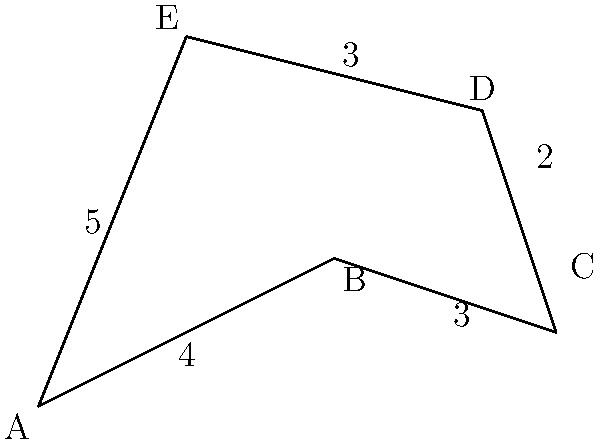As a political advisor aiming to become the youngest UN Secretary-General, you're analyzing a map of a disputed territory. The irregular polygon ABCDE represents the contested borders. Given that the lengths of the sides are AB = 4 units, BC = 3 units, CD = 2 units, DE = 3 units, and EA = 5 units, what is the perimeter of this territory in units? To find the perimeter of the irregular polygon ABCDE, we need to sum up the lengths of all its sides. Let's break it down step by step:

1. Side AB = 4 units
2. Side BC = 3 units
3. Side CD = 2 units
4. Side DE = 3 units
5. Side EA = 5 units

Now, we can calculate the perimeter by adding all these lengths:

$$\text{Perimeter} = AB + BC + CD + DE + EA$$
$$\text{Perimeter} = 4 + 3 + 2 + 3 + 5$$
$$\text{Perimeter} = 17$$

Therefore, the perimeter of the irregular polygon representing the contested borders is 17 units.
Answer: 17 units 